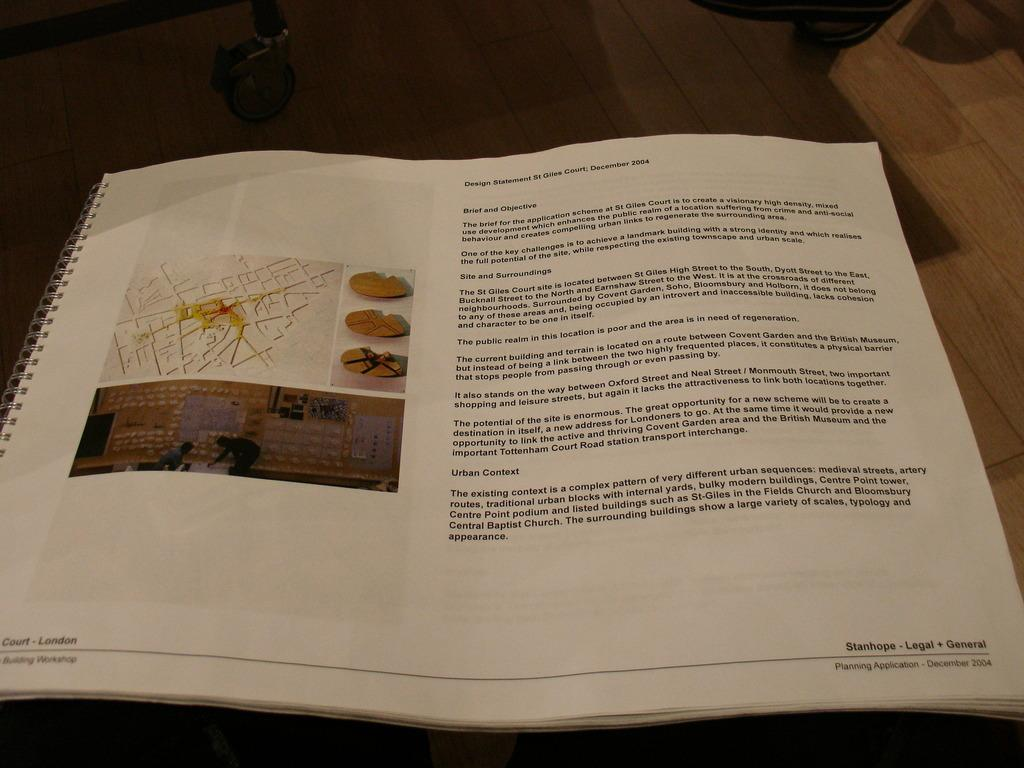<image>
Share a concise interpretation of the image provided. The open page of a book which has the words Stanhope Legal General at the bottom left. 